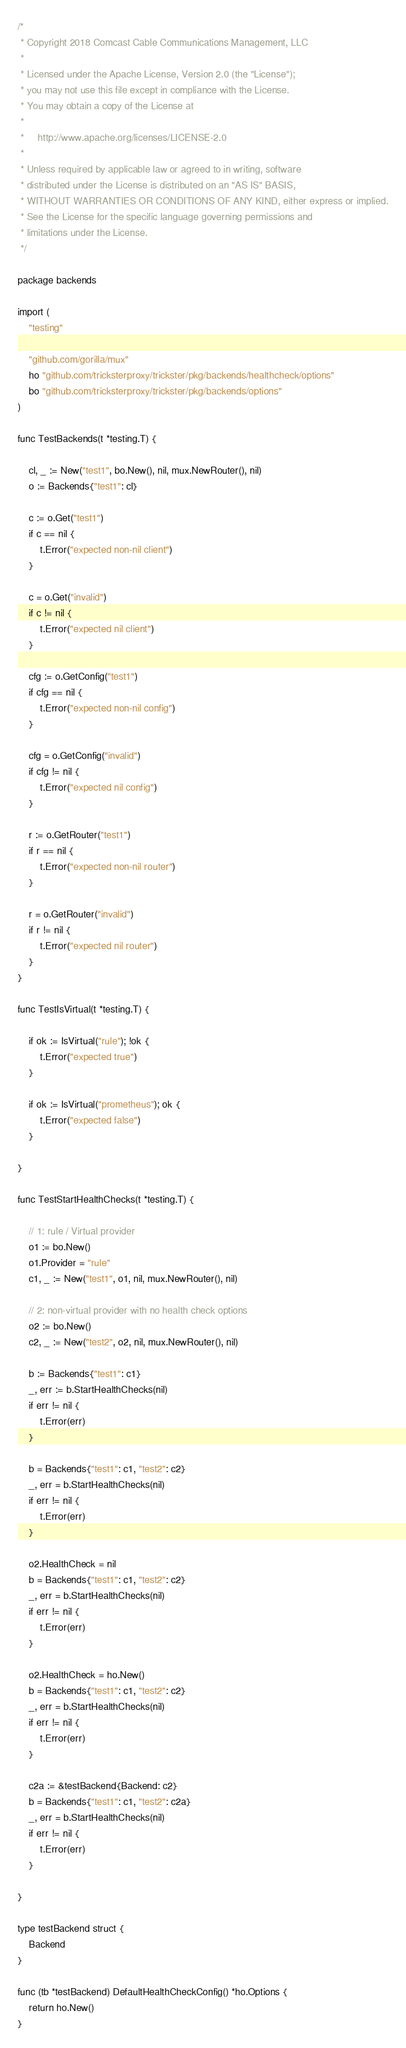Convert code to text. <code><loc_0><loc_0><loc_500><loc_500><_Go_>/*
 * Copyright 2018 Comcast Cable Communications Management, LLC
 *
 * Licensed under the Apache License, Version 2.0 (the "License");
 * you may not use this file except in compliance with the License.
 * You may obtain a copy of the License at
 *
 *     http://www.apache.org/licenses/LICENSE-2.0
 *
 * Unless required by applicable law or agreed to in writing, software
 * distributed under the License is distributed on an "AS IS" BASIS,
 * WITHOUT WARRANTIES OR CONDITIONS OF ANY KIND, either express or implied.
 * See the License for the specific language governing permissions and
 * limitations under the License.
 */

package backends

import (
	"testing"

	"github.com/gorilla/mux"
	ho "github.com/tricksterproxy/trickster/pkg/backends/healthcheck/options"
	bo "github.com/tricksterproxy/trickster/pkg/backends/options"
)

func TestBackends(t *testing.T) {

	cl, _ := New("test1", bo.New(), nil, mux.NewRouter(), nil)
	o := Backends{"test1": cl}

	c := o.Get("test1")
	if c == nil {
		t.Error("expected non-nil client")
	}

	c = o.Get("invalid")
	if c != nil {
		t.Error("expected nil client")
	}

	cfg := o.GetConfig("test1")
	if cfg == nil {
		t.Error("expected non-nil config")
	}

	cfg = o.GetConfig("invalid")
	if cfg != nil {
		t.Error("expected nil config")
	}

	r := o.GetRouter("test1")
	if r == nil {
		t.Error("expected non-nil router")
	}

	r = o.GetRouter("invalid")
	if r != nil {
		t.Error("expected nil router")
	}
}

func TestIsVirtual(t *testing.T) {

	if ok := IsVirtual("rule"); !ok {
		t.Error("expected true")
	}

	if ok := IsVirtual("prometheus"); ok {
		t.Error("expected false")
	}

}

func TestStartHealthChecks(t *testing.T) {

	// 1: rule / Virtual provider
	o1 := bo.New()
	o1.Provider = "rule"
	c1, _ := New("test1", o1, nil, mux.NewRouter(), nil)

	// 2: non-virtual provider with no health check options
	o2 := bo.New()
	c2, _ := New("test2", o2, nil, mux.NewRouter(), nil)

	b := Backends{"test1": c1}
	_, err := b.StartHealthChecks(nil)
	if err != nil {
		t.Error(err)
	}

	b = Backends{"test1": c1, "test2": c2}
	_, err = b.StartHealthChecks(nil)
	if err != nil {
		t.Error(err)
	}

	o2.HealthCheck = nil
	b = Backends{"test1": c1, "test2": c2}
	_, err = b.StartHealthChecks(nil)
	if err != nil {
		t.Error(err)
	}

	o2.HealthCheck = ho.New()
	b = Backends{"test1": c1, "test2": c2}
	_, err = b.StartHealthChecks(nil)
	if err != nil {
		t.Error(err)
	}

	c2a := &testBackend{Backend: c2}
	b = Backends{"test1": c1, "test2": c2a}
	_, err = b.StartHealthChecks(nil)
	if err != nil {
		t.Error(err)
	}

}

type testBackend struct {
	Backend
}

func (tb *testBackend) DefaultHealthCheckConfig() *ho.Options {
	return ho.New()
}
</code> 